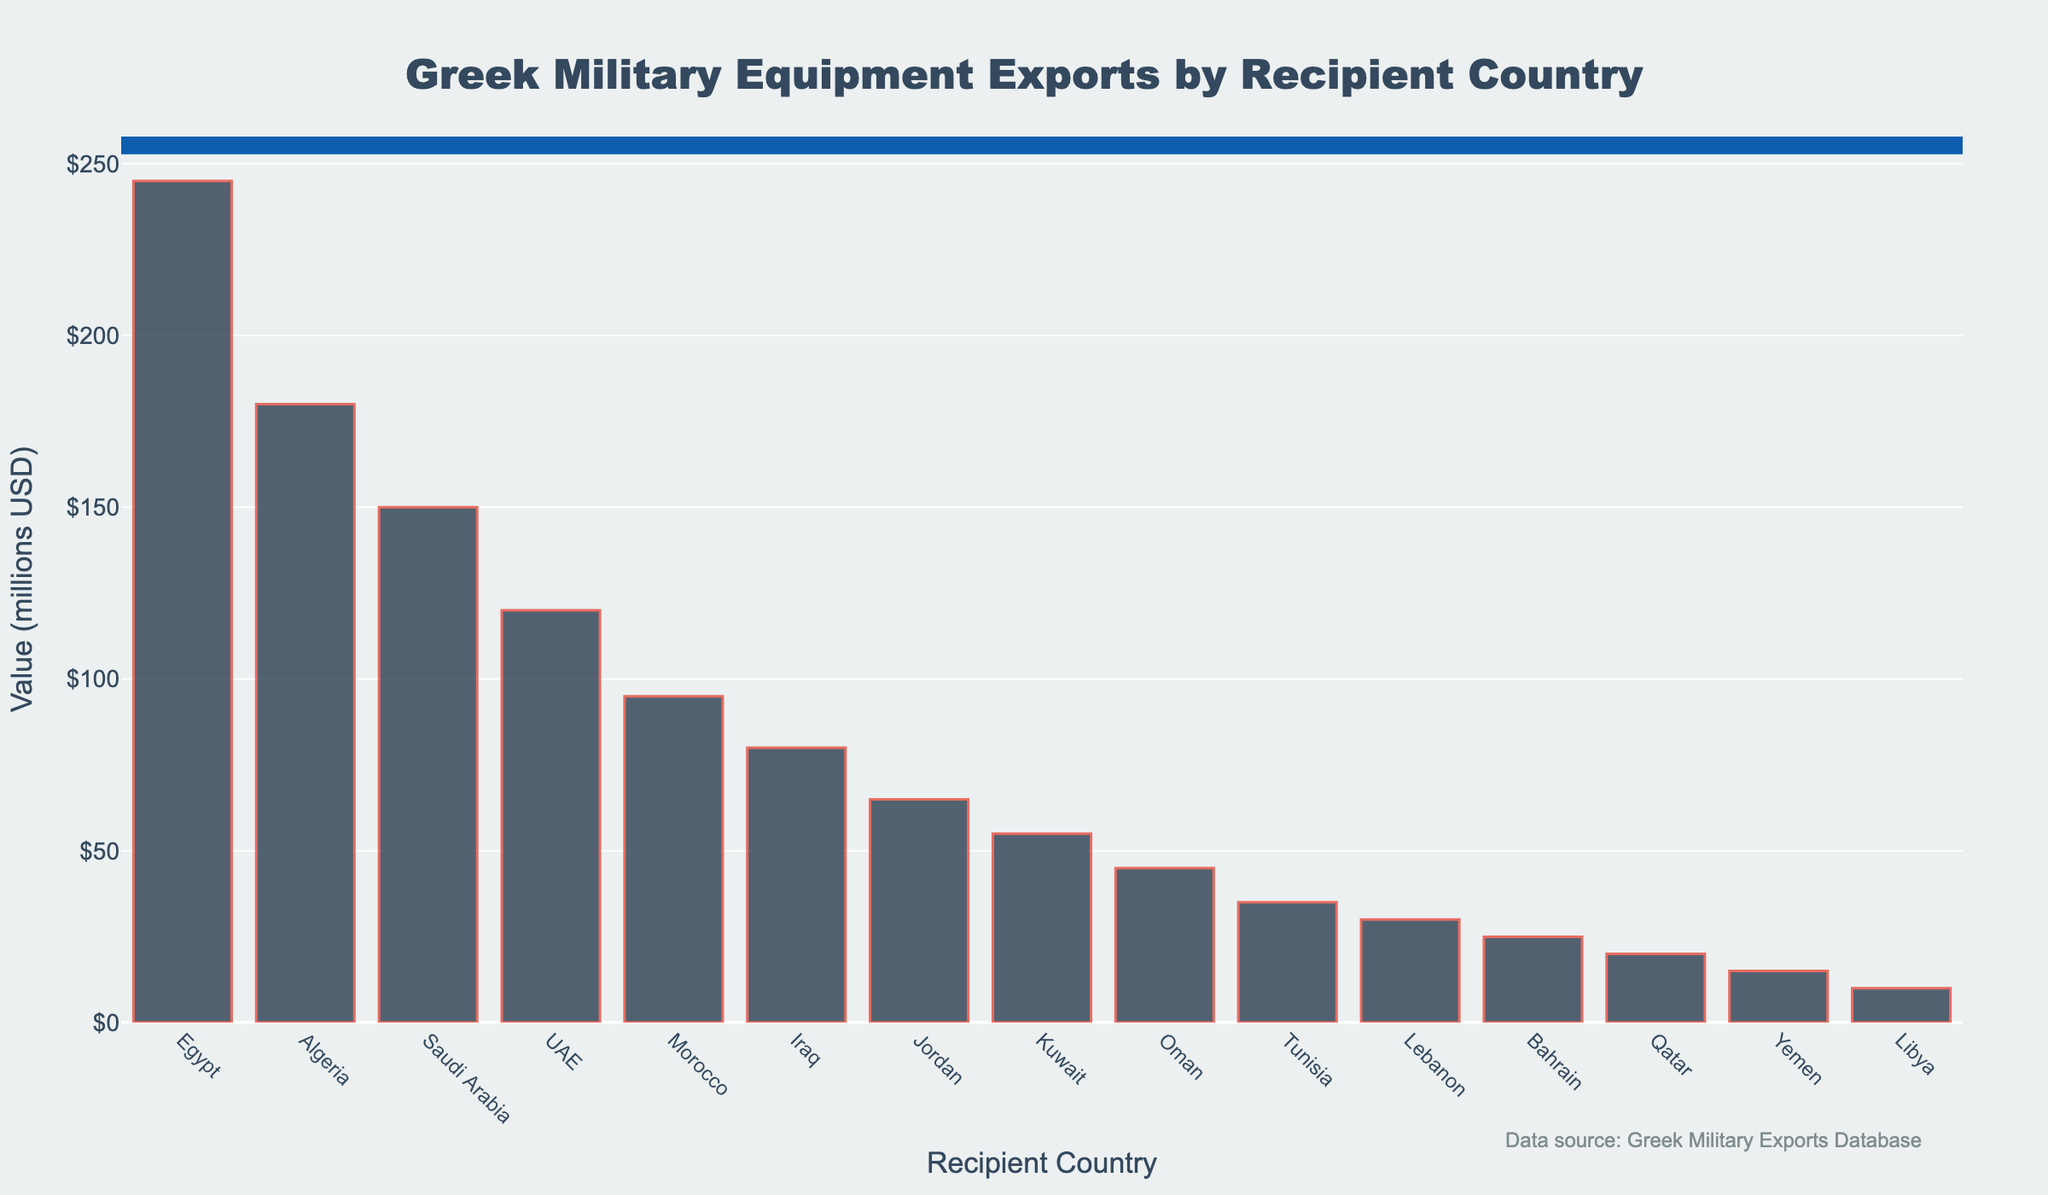Which recipient country has the highest value of Greek military equipment exports? By looking at the height of the bars, the bar for Egypt is the tallest, indicating the highest value of military equipment exports.
Answer: Egypt What is the total value of Greek military equipment exports to Algeria and Saudi Arabia? The value of Greek military equipment exports to Algeria is 180 million USD, and for Saudi Arabia, it is 150 million USD. Adding these together, 180 + 150 = 330 million USD.
Answer: 330 million USD Which country has received less military equipment exports from Greece, Lebanon or Bahrain? The bar for Lebanon is slightly shorter than the bar for Bahrain, indicating a lower value.
Answer: Lebanon How much more is the value of exports to Egypt compared to Iraq? The value for Egypt is 245 million USD, and for Iraq is 80 million USD. The difference is 245 - 80 = 165 million USD.
Answer: 165 million USD Which are the recipient countries that have received exports valued at exactly 55 million USD or below? The bars for Kuwait, Oman, Tunisia, Lebanon, Bahrain, Qatar, Yemen, and Libya all have values of 55 million USD or below.
Answer: Kuwait, Oman, Tunisia, Lebanon, Bahrain, Qatar, Yemen, Libya What is the combined value of exports to the UAE, Morocco, and Jordan? The value for UAE is 120 million USD, for Morocco is 95 million USD, and for Jordan is 65 million USD. Adding these together, 120 + 95 + 65 = 280 million USD.
Answer: 280 million USD Which two countries have the closest values of military equipment exports, and what are those values? By examining the heights of the bars, we can see that the values for Qatar and Yemen are very close. Qatar has 20 million USD, and Yemen has 15 million USD, with a difference of only 5 million USD between them.
Answer: Qatar: 20 million USD, Yemen: 15 million USD What is the average value of military equipment exports to the top three recipient countries? The top three countries are Egypt (245 million USD), Algeria (180 million USD), and Saudi Arabia (150 million USD). Calculating the average: (245 + 180 + 150) / 3 = 575 / 3 = 191.67 million USD.
Answer: 191.67 million USD 